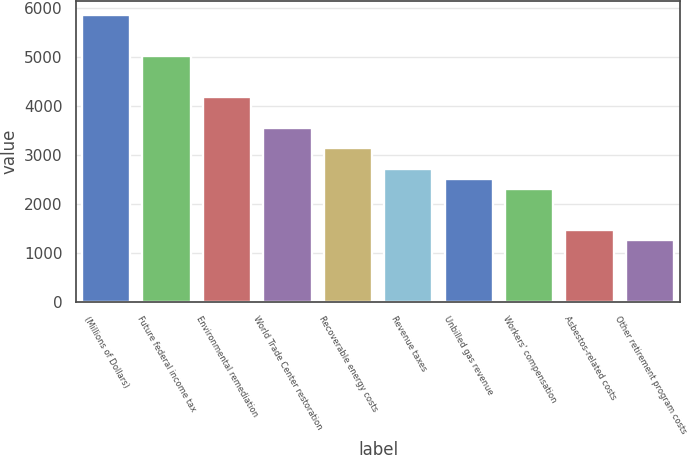Convert chart to OTSL. <chart><loc_0><loc_0><loc_500><loc_500><bar_chart><fcel>(Millions of Dollars)<fcel>Future federal income tax<fcel>Environmental remediation<fcel>World Trade Center restoration<fcel>Recoverable energy costs<fcel>Revenue taxes<fcel>Unbilled gas revenue<fcel>Workers' compensation<fcel>Asbestos-related costs<fcel>Other retirement program costs<nl><fcel>5856<fcel>5020<fcel>4184<fcel>3557<fcel>3139<fcel>2721<fcel>2512<fcel>2303<fcel>1467<fcel>1258<nl></chart> 